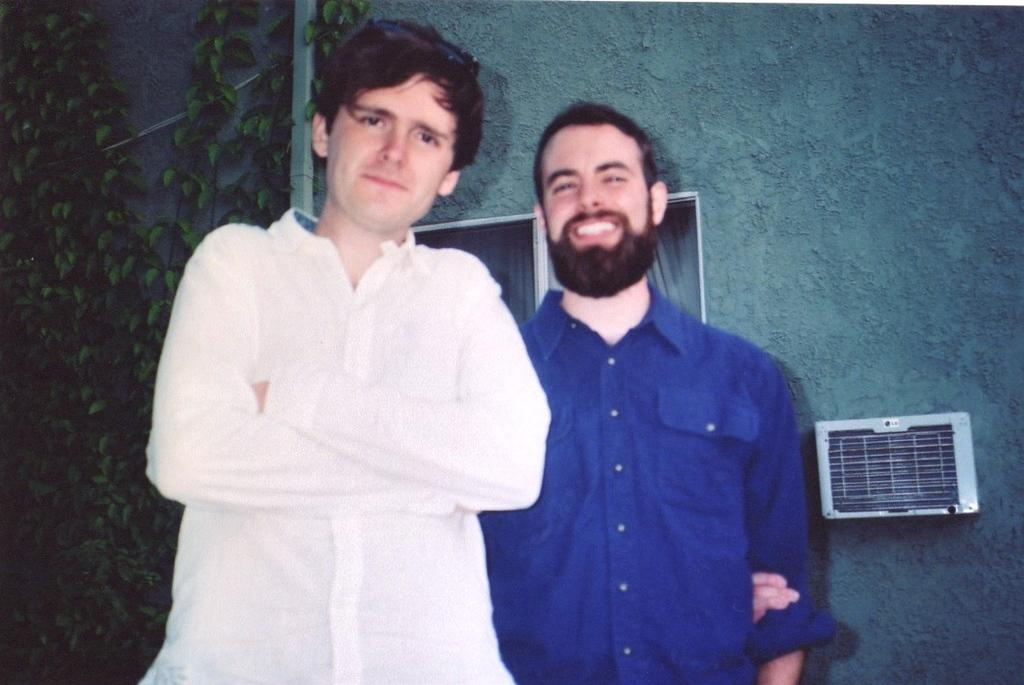How many people are standing in the image? There are two people standing in the image. What can be seen in the background? There is a wall in the background. What features are present on the wall? There are windows and creepers on the wall. Is there any object attached to the wall? Yes, there is a white color box on the wall. What part of their body are the people using to wash the windows in the image? There is no indication in the image that the people are washing the windows, and therefore no body part can be identified for this purpose. 